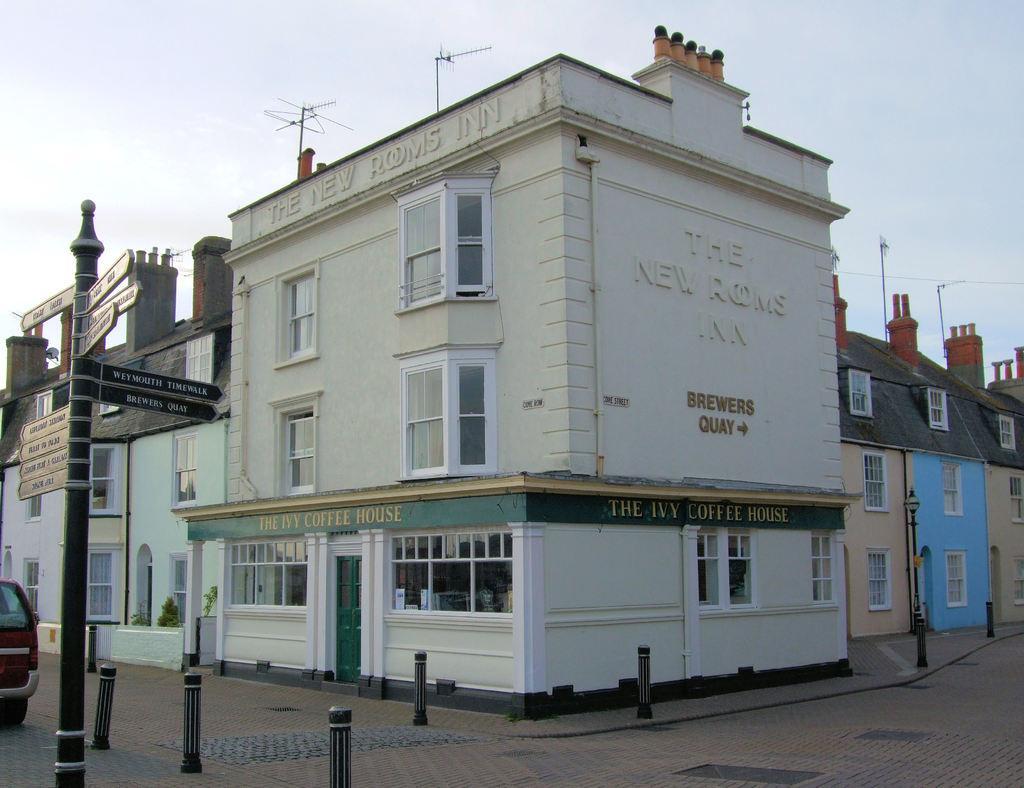Can you describe this image briefly? In this image we can see buildings, windows, there are light poles, boards with text on them, there are poles, there are text on the wall, there are signal receivers, plants, also we can see a car, and the sky. 